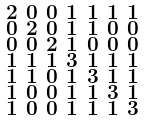Convert formula to latex. <formula><loc_0><loc_0><loc_500><loc_500>\begin{smallmatrix} 2 & 0 & 0 & 1 & 1 & 1 & 1 \\ 0 & 2 & 0 & 1 & 1 & 0 & 0 \\ 0 & 0 & 2 & 1 & 0 & 0 & 0 \\ 1 & 1 & 1 & 3 & 1 & 1 & 1 \\ 1 & 1 & 0 & 1 & 3 & 1 & 1 \\ 1 & 0 & 0 & 1 & 1 & 3 & 1 \\ 1 & 0 & 0 & 1 & 1 & 1 & 3 \end{smallmatrix}</formula> 